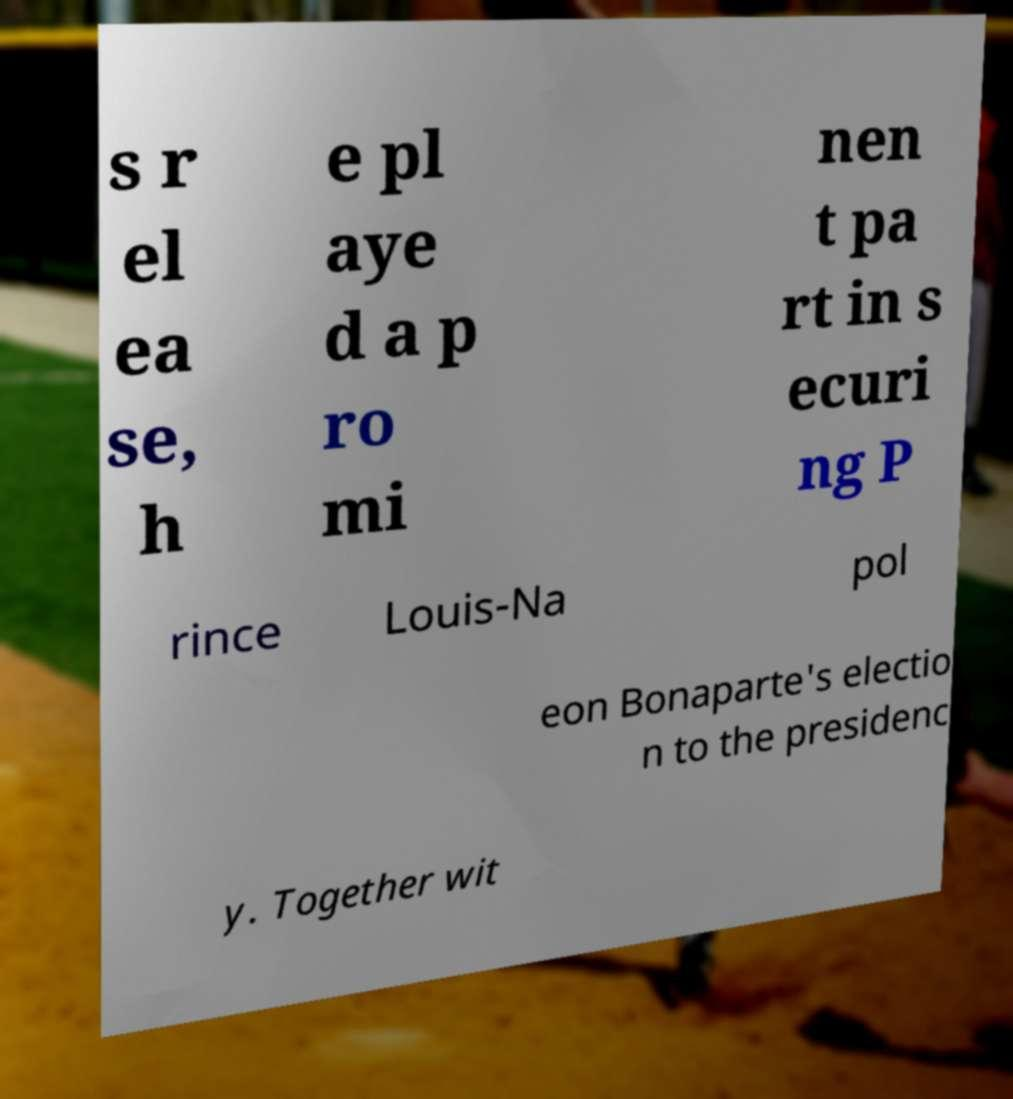There's text embedded in this image that I need extracted. Can you transcribe it verbatim? s r el ea se, h e pl aye d a p ro mi nen t pa rt in s ecuri ng P rince Louis-Na pol eon Bonaparte's electio n to the presidenc y. Together wit 